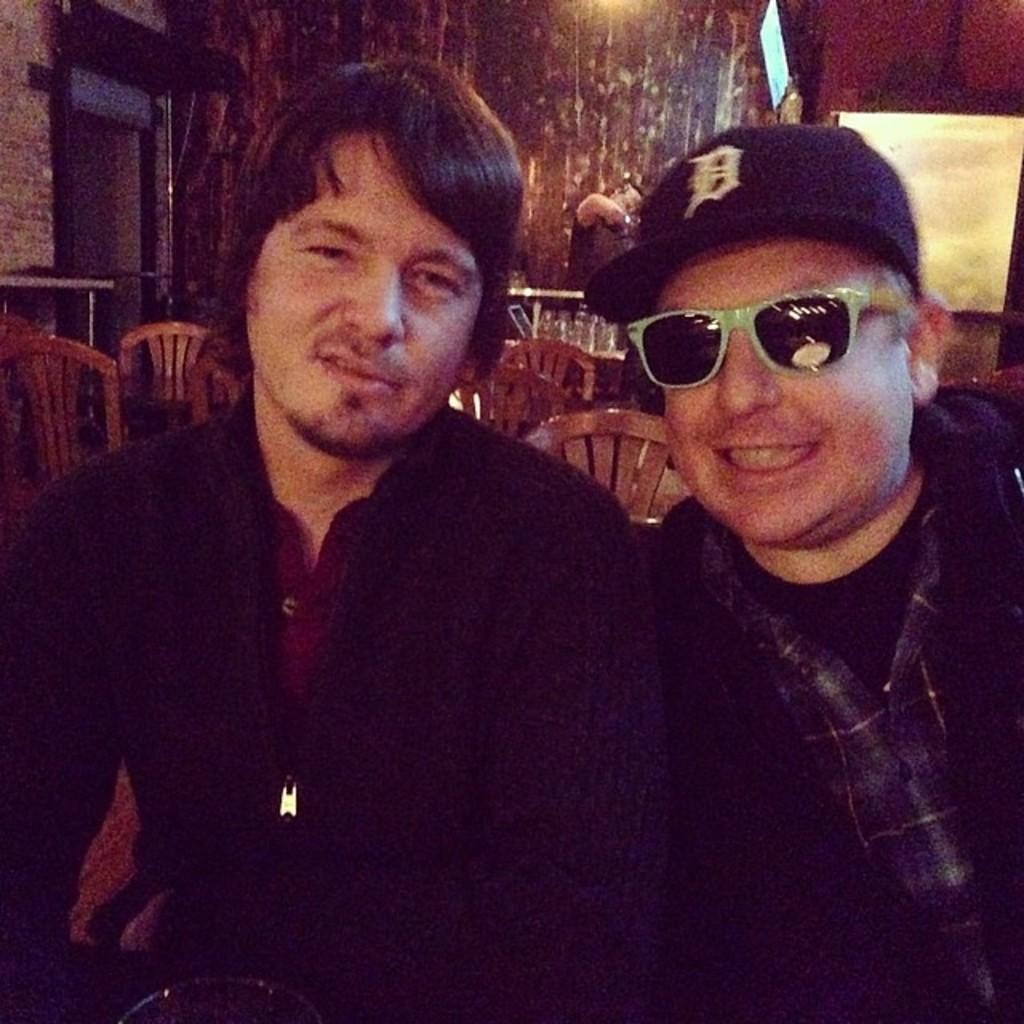How many people are in the image? There are two persons in the image. What accessories are worn by the people in the image? One person is wearing a cap, and another person is wearing spectacles. What type of monkey can be seen climbing on the person wearing the cap in the image? There is no monkey present in the image. Can you tell me how many squirrels are sitting on the person wearing spectacles in the image? There are no squirrels present in the image. 